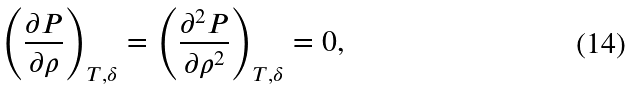Convert formula to latex. <formula><loc_0><loc_0><loc_500><loc_500>\left ( \frac { \partial P } { \partial \rho } \right ) _ { T , \delta } = \left ( \frac { \partial ^ { 2 } P } { \partial \rho ^ { 2 } } \right ) _ { T , \delta } = 0 ,</formula> 